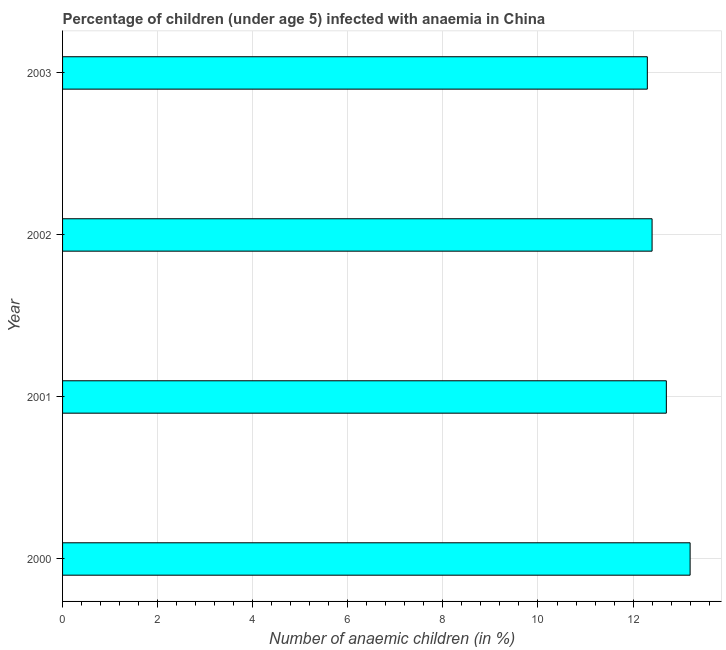Does the graph contain grids?
Provide a succinct answer. Yes. What is the title of the graph?
Your response must be concise. Percentage of children (under age 5) infected with anaemia in China. What is the label or title of the X-axis?
Your answer should be compact. Number of anaemic children (in %). Across all years, what is the maximum number of anaemic children?
Offer a very short reply. 13.2. Across all years, what is the minimum number of anaemic children?
Make the answer very short. 12.3. In which year was the number of anaemic children minimum?
Make the answer very short. 2003. What is the sum of the number of anaemic children?
Your answer should be compact. 50.6. What is the average number of anaemic children per year?
Ensure brevity in your answer.  12.65. What is the median number of anaemic children?
Offer a terse response. 12.55. Do a majority of the years between 2003 and 2001 (inclusive) have number of anaemic children greater than 8.4 %?
Your response must be concise. Yes. What is the ratio of the number of anaemic children in 2000 to that in 2001?
Your response must be concise. 1.04. Is the difference between the number of anaemic children in 2002 and 2003 greater than the difference between any two years?
Offer a terse response. No. What is the difference between the highest and the second highest number of anaemic children?
Make the answer very short. 0.5. Is the sum of the number of anaemic children in 2000 and 2003 greater than the maximum number of anaemic children across all years?
Offer a terse response. Yes. How many years are there in the graph?
Keep it short and to the point. 4. What is the Number of anaemic children (in %) of 2000?
Provide a short and direct response. 13.2. What is the Number of anaemic children (in %) in 2002?
Offer a terse response. 12.4. What is the difference between the Number of anaemic children (in %) in 2000 and 2003?
Your response must be concise. 0.9. What is the difference between the Number of anaemic children (in %) in 2001 and 2002?
Make the answer very short. 0.3. What is the difference between the Number of anaemic children (in %) in 2001 and 2003?
Make the answer very short. 0.4. What is the ratio of the Number of anaemic children (in %) in 2000 to that in 2001?
Your response must be concise. 1.04. What is the ratio of the Number of anaemic children (in %) in 2000 to that in 2002?
Offer a very short reply. 1.06. What is the ratio of the Number of anaemic children (in %) in 2000 to that in 2003?
Your answer should be very brief. 1.07. What is the ratio of the Number of anaemic children (in %) in 2001 to that in 2002?
Ensure brevity in your answer.  1.02. What is the ratio of the Number of anaemic children (in %) in 2001 to that in 2003?
Ensure brevity in your answer.  1.03. What is the ratio of the Number of anaemic children (in %) in 2002 to that in 2003?
Ensure brevity in your answer.  1.01. 